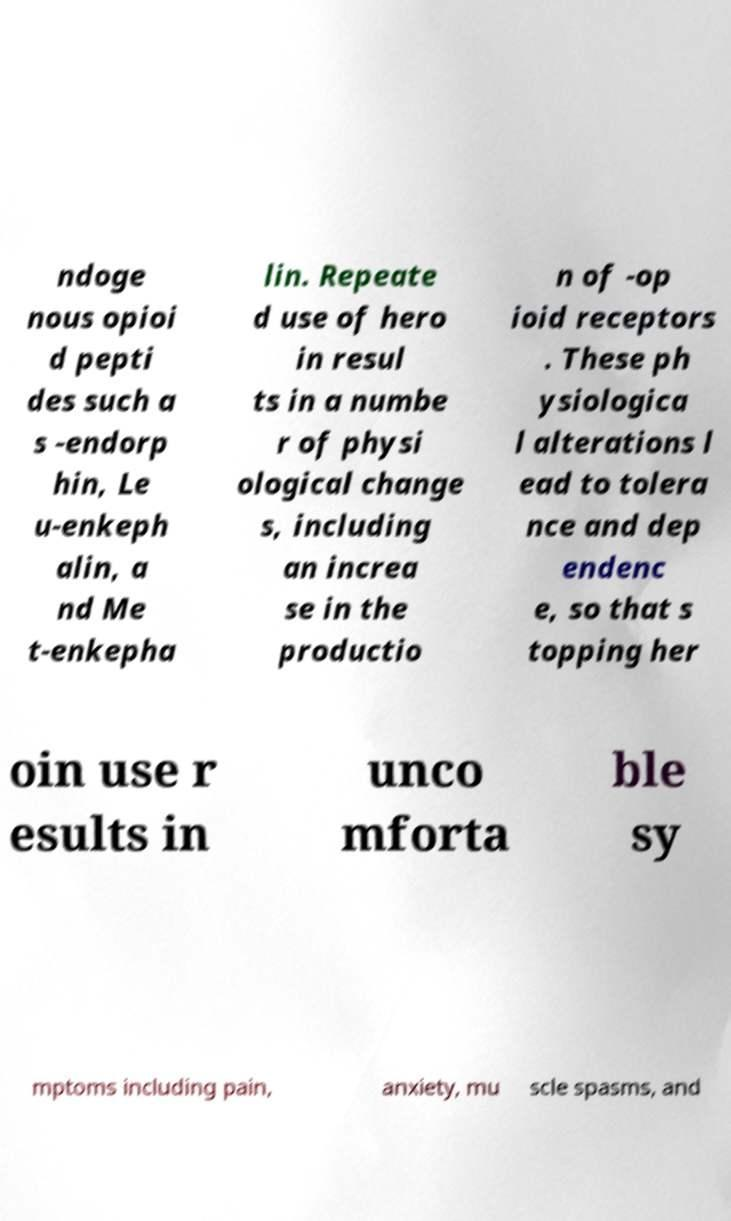Please read and relay the text visible in this image. What does it say? ndoge nous opioi d pepti des such a s -endorp hin, Le u-enkeph alin, a nd Me t-enkepha lin. Repeate d use of hero in resul ts in a numbe r of physi ological change s, including an increa se in the productio n of -op ioid receptors . These ph ysiologica l alterations l ead to tolera nce and dep endenc e, so that s topping her oin use r esults in unco mforta ble sy mptoms including pain, anxiety, mu scle spasms, and 